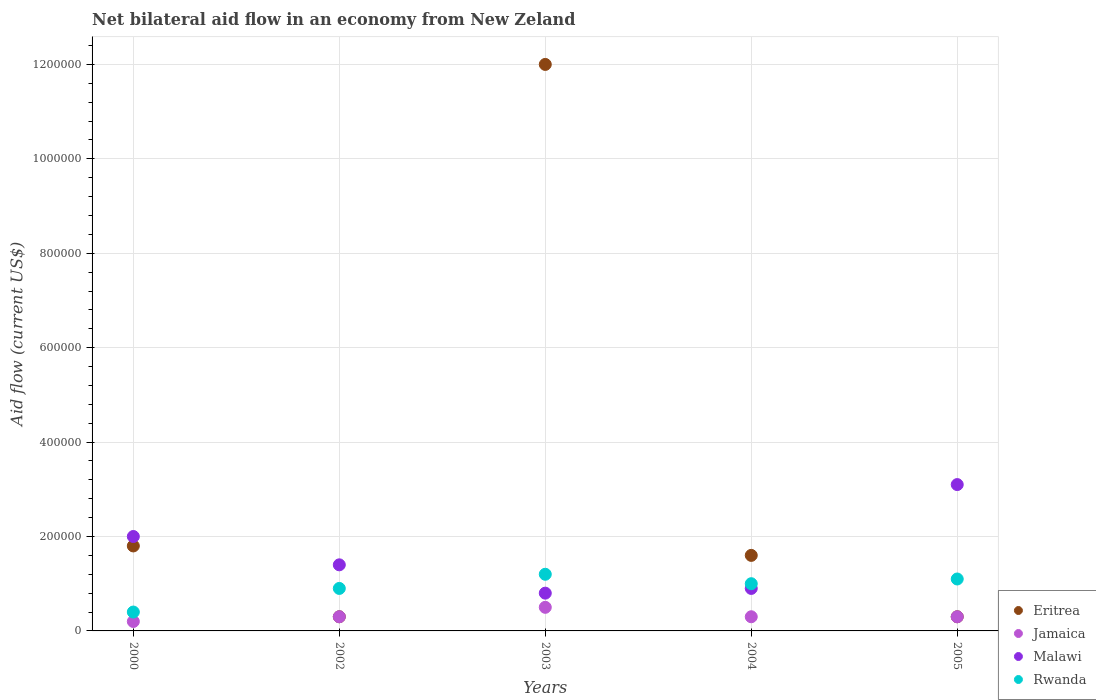How many different coloured dotlines are there?
Your answer should be compact. 4. Is the number of dotlines equal to the number of legend labels?
Keep it short and to the point. Yes. What is the net bilateral aid flow in Jamaica in 2000?
Offer a very short reply. 2.00e+04. In which year was the net bilateral aid flow in Eritrea maximum?
Provide a short and direct response. 2003. What is the total net bilateral aid flow in Eritrea in the graph?
Make the answer very short. 1.60e+06. What is the difference between the net bilateral aid flow in Jamaica in 2003 and the net bilateral aid flow in Eritrea in 2000?
Your answer should be very brief. -1.30e+05. What is the average net bilateral aid flow in Rwanda per year?
Provide a short and direct response. 9.20e+04. In the year 2000, what is the difference between the net bilateral aid flow in Malawi and net bilateral aid flow in Jamaica?
Provide a short and direct response. 1.80e+05. Is the difference between the net bilateral aid flow in Malawi in 2002 and 2004 greater than the difference between the net bilateral aid flow in Jamaica in 2002 and 2004?
Provide a succinct answer. Yes. What is the difference between the highest and the lowest net bilateral aid flow in Rwanda?
Ensure brevity in your answer.  8.00e+04. In how many years, is the net bilateral aid flow in Jamaica greater than the average net bilateral aid flow in Jamaica taken over all years?
Keep it short and to the point. 1. Is it the case that in every year, the sum of the net bilateral aid flow in Rwanda and net bilateral aid flow in Malawi  is greater than the sum of net bilateral aid flow in Eritrea and net bilateral aid flow in Jamaica?
Keep it short and to the point. Yes. Is the net bilateral aid flow in Rwanda strictly less than the net bilateral aid flow in Jamaica over the years?
Ensure brevity in your answer.  No. How many dotlines are there?
Offer a very short reply. 4. How many years are there in the graph?
Ensure brevity in your answer.  5. Does the graph contain grids?
Provide a succinct answer. Yes. How many legend labels are there?
Provide a succinct answer. 4. How are the legend labels stacked?
Ensure brevity in your answer.  Vertical. What is the title of the graph?
Offer a very short reply. Net bilateral aid flow in an economy from New Zeland. Does "Niger" appear as one of the legend labels in the graph?
Keep it short and to the point. No. What is the label or title of the X-axis?
Provide a succinct answer. Years. What is the label or title of the Y-axis?
Your answer should be compact. Aid flow (current US$). What is the Aid flow (current US$) of Jamaica in 2000?
Provide a succinct answer. 2.00e+04. What is the Aid flow (current US$) in Rwanda in 2000?
Offer a very short reply. 4.00e+04. What is the Aid flow (current US$) of Malawi in 2002?
Your answer should be compact. 1.40e+05. What is the Aid flow (current US$) of Eritrea in 2003?
Provide a short and direct response. 1.20e+06. What is the Aid flow (current US$) in Jamaica in 2003?
Provide a succinct answer. 5.00e+04. What is the Aid flow (current US$) of Rwanda in 2003?
Offer a very short reply. 1.20e+05. What is the Aid flow (current US$) of Eritrea in 2004?
Offer a terse response. 1.60e+05. What is the Aid flow (current US$) in Malawi in 2004?
Your answer should be very brief. 9.00e+04. What is the Aid flow (current US$) of Jamaica in 2005?
Your answer should be very brief. 3.00e+04. What is the Aid flow (current US$) in Rwanda in 2005?
Ensure brevity in your answer.  1.10e+05. Across all years, what is the maximum Aid flow (current US$) of Eritrea?
Ensure brevity in your answer.  1.20e+06. Across all years, what is the maximum Aid flow (current US$) in Jamaica?
Ensure brevity in your answer.  5.00e+04. Across all years, what is the maximum Aid flow (current US$) of Malawi?
Provide a succinct answer. 3.10e+05. Across all years, what is the maximum Aid flow (current US$) in Rwanda?
Give a very brief answer. 1.20e+05. Across all years, what is the minimum Aid flow (current US$) in Eritrea?
Provide a succinct answer. 3.00e+04. What is the total Aid flow (current US$) in Eritrea in the graph?
Your response must be concise. 1.60e+06. What is the total Aid flow (current US$) of Malawi in the graph?
Your response must be concise. 8.20e+05. What is the difference between the Aid flow (current US$) in Jamaica in 2000 and that in 2002?
Provide a succinct answer. -10000. What is the difference between the Aid flow (current US$) in Malawi in 2000 and that in 2002?
Make the answer very short. 6.00e+04. What is the difference between the Aid flow (current US$) in Rwanda in 2000 and that in 2002?
Ensure brevity in your answer.  -5.00e+04. What is the difference between the Aid flow (current US$) in Eritrea in 2000 and that in 2003?
Keep it short and to the point. -1.02e+06. What is the difference between the Aid flow (current US$) in Jamaica in 2000 and that in 2003?
Provide a succinct answer. -3.00e+04. What is the difference between the Aid flow (current US$) of Eritrea in 2000 and that in 2004?
Give a very brief answer. 2.00e+04. What is the difference between the Aid flow (current US$) in Jamaica in 2000 and that in 2004?
Give a very brief answer. -10000. What is the difference between the Aid flow (current US$) of Rwanda in 2000 and that in 2004?
Offer a very short reply. -6.00e+04. What is the difference between the Aid flow (current US$) in Eritrea in 2000 and that in 2005?
Give a very brief answer. 1.50e+05. What is the difference between the Aid flow (current US$) in Jamaica in 2000 and that in 2005?
Your answer should be very brief. -10000. What is the difference between the Aid flow (current US$) in Eritrea in 2002 and that in 2003?
Offer a terse response. -1.17e+06. What is the difference between the Aid flow (current US$) of Malawi in 2002 and that in 2003?
Offer a very short reply. 6.00e+04. What is the difference between the Aid flow (current US$) in Jamaica in 2002 and that in 2005?
Your answer should be very brief. 0. What is the difference between the Aid flow (current US$) of Eritrea in 2003 and that in 2004?
Provide a short and direct response. 1.04e+06. What is the difference between the Aid flow (current US$) of Jamaica in 2003 and that in 2004?
Offer a very short reply. 2.00e+04. What is the difference between the Aid flow (current US$) of Eritrea in 2003 and that in 2005?
Ensure brevity in your answer.  1.17e+06. What is the difference between the Aid flow (current US$) in Malawi in 2003 and that in 2005?
Ensure brevity in your answer.  -2.30e+05. What is the difference between the Aid flow (current US$) in Rwanda in 2003 and that in 2005?
Ensure brevity in your answer.  10000. What is the difference between the Aid flow (current US$) of Eritrea in 2004 and that in 2005?
Your response must be concise. 1.30e+05. What is the difference between the Aid flow (current US$) in Eritrea in 2000 and the Aid flow (current US$) in Malawi in 2002?
Your answer should be very brief. 4.00e+04. What is the difference between the Aid flow (current US$) in Eritrea in 2000 and the Aid flow (current US$) in Rwanda in 2002?
Make the answer very short. 9.00e+04. What is the difference between the Aid flow (current US$) in Jamaica in 2000 and the Aid flow (current US$) in Malawi in 2002?
Provide a succinct answer. -1.20e+05. What is the difference between the Aid flow (current US$) of Jamaica in 2000 and the Aid flow (current US$) of Rwanda in 2002?
Your response must be concise. -7.00e+04. What is the difference between the Aid flow (current US$) in Eritrea in 2000 and the Aid flow (current US$) in Malawi in 2003?
Your response must be concise. 1.00e+05. What is the difference between the Aid flow (current US$) in Eritrea in 2000 and the Aid flow (current US$) in Rwanda in 2003?
Your answer should be compact. 6.00e+04. What is the difference between the Aid flow (current US$) of Malawi in 2000 and the Aid flow (current US$) of Rwanda in 2003?
Offer a terse response. 8.00e+04. What is the difference between the Aid flow (current US$) of Jamaica in 2000 and the Aid flow (current US$) of Rwanda in 2004?
Keep it short and to the point. -8.00e+04. What is the difference between the Aid flow (current US$) in Malawi in 2000 and the Aid flow (current US$) in Rwanda in 2004?
Make the answer very short. 1.00e+05. What is the difference between the Aid flow (current US$) of Eritrea in 2000 and the Aid flow (current US$) of Jamaica in 2005?
Give a very brief answer. 1.50e+05. What is the difference between the Aid flow (current US$) of Eritrea in 2000 and the Aid flow (current US$) of Malawi in 2005?
Offer a very short reply. -1.30e+05. What is the difference between the Aid flow (current US$) of Eritrea in 2000 and the Aid flow (current US$) of Rwanda in 2005?
Your answer should be very brief. 7.00e+04. What is the difference between the Aid flow (current US$) of Jamaica in 2000 and the Aid flow (current US$) of Malawi in 2005?
Your answer should be compact. -2.90e+05. What is the difference between the Aid flow (current US$) of Jamaica in 2000 and the Aid flow (current US$) of Rwanda in 2005?
Make the answer very short. -9.00e+04. What is the difference between the Aid flow (current US$) of Eritrea in 2002 and the Aid flow (current US$) of Jamaica in 2003?
Offer a terse response. -2.00e+04. What is the difference between the Aid flow (current US$) of Eritrea in 2002 and the Aid flow (current US$) of Malawi in 2003?
Give a very brief answer. -5.00e+04. What is the difference between the Aid flow (current US$) of Eritrea in 2002 and the Aid flow (current US$) of Rwanda in 2003?
Give a very brief answer. -9.00e+04. What is the difference between the Aid flow (current US$) of Jamaica in 2002 and the Aid flow (current US$) of Rwanda in 2003?
Keep it short and to the point. -9.00e+04. What is the difference between the Aid flow (current US$) in Malawi in 2002 and the Aid flow (current US$) in Rwanda in 2003?
Provide a succinct answer. 2.00e+04. What is the difference between the Aid flow (current US$) in Eritrea in 2002 and the Aid flow (current US$) in Jamaica in 2004?
Your answer should be very brief. 0. What is the difference between the Aid flow (current US$) in Jamaica in 2002 and the Aid flow (current US$) in Malawi in 2004?
Your response must be concise. -6.00e+04. What is the difference between the Aid flow (current US$) in Malawi in 2002 and the Aid flow (current US$) in Rwanda in 2004?
Provide a short and direct response. 4.00e+04. What is the difference between the Aid flow (current US$) of Eritrea in 2002 and the Aid flow (current US$) of Jamaica in 2005?
Provide a short and direct response. 0. What is the difference between the Aid flow (current US$) in Eritrea in 2002 and the Aid flow (current US$) in Malawi in 2005?
Provide a short and direct response. -2.80e+05. What is the difference between the Aid flow (current US$) in Jamaica in 2002 and the Aid flow (current US$) in Malawi in 2005?
Provide a short and direct response. -2.80e+05. What is the difference between the Aid flow (current US$) of Jamaica in 2002 and the Aid flow (current US$) of Rwanda in 2005?
Your answer should be compact. -8.00e+04. What is the difference between the Aid flow (current US$) in Eritrea in 2003 and the Aid flow (current US$) in Jamaica in 2004?
Ensure brevity in your answer.  1.17e+06. What is the difference between the Aid flow (current US$) in Eritrea in 2003 and the Aid flow (current US$) in Malawi in 2004?
Ensure brevity in your answer.  1.11e+06. What is the difference between the Aid flow (current US$) of Eritrea in 2003 and the Aid flow (current US$) of Rwanda in 2004?
Provide a short and direct response. 1.10e+06. What is the difference between the Aid flow (current US$) in Jamaica in 2003 and the Aid flow (current US$) in Malawi in 2004?
Your response must be concise. -4.00e+04. What is the difference between the Aid flow (current US$) of Eritrea in 2003 and the Aid flow (current US$) of Jamaica in 2005?
Provide a succinct answer. 1.17e+06. What is the difference between the Aid flow (current US$) in Eritrea in 2003 and the Aid flow (current US$) in Malawi in 2005?
Your answer should be very brief. 8.90e+05. What is the difference between the Aid flow (current US$) in Eritrea in 2003 and the Aid flow (current US$) in Rwanda in 2005?
Offer a terse response. 1.09e+06. What is the difference between the Aid flow (current US$) of Jamaica in 2003 and the Aid flow (current US$) of Malawi in 2005?
Provide a short and direct response. -2.60e+05. What is the difference between the Aid flow (current US$) of Malawi in 2003 and the Aid flow (current US$) of Rwanda in 2005?
Ensure brevity in your answer.  -3.00e+04. What is the difference between the Aid flow (current US$) in Eritrea in 2004 and the Aid flow (current US$) in Jamaica in 2005?
Provide a succinct answer. 1.30e+05. What is the difference between the Aid flow (current US$) of Eritrea in 2004 and the Aid flow (current US$) of Malawi in 2005?
Provide a succinct answer. -1.50e+05. What is the difference between the Aid flow (current US$) of Jamaica in 2004 and the Aid flow (current US$) of Malawi in 2005?
Keep it short and to the point. -2.80e+05. What is the difference between the Aid flow (current US$) of Malawi in 2004 and the Aid flow (current US$) of Rwanda in 2005?
Provide a short and direct response. -2.00e+04. What is the average Aid flow (current US$) of Jamaica per year?
Offer a very short reply. 3.20e+04. What is the average Aid flow (current US$) in Malawi per year?
Make the answer very short. 1.64e+05. What is the average Aid flow (current US$) of Rwanda per year?
Your answer should be very brief. 9.20e+04. In the year 2000, what is the difference between the Aid flow (current US$) of Eritrea and Aid flow (current US$) of Jamaica?
Make the answer very short. 1.60e+05. In the year 2000, what is the difference between the Aid flow (current US$) in Eritrea and Aid flow (current US$) in Rwanda?
Ensure brevity in your answer.  1.40e+05. In the year 2000, what is the difference between the Aid flow (current US$) in Jamaica and Aid flow (current US$) in Malawi?
Offer a very short reply. -1.80e+05. In the year 2000, what is the difference between the Aid flow (current US$) of Jamaica and Aid flow (current US$) of Rwanda?
Offer a terse response. -2.00e+04. In the year 2002, what is the difference between the Aid flow (current US$) in Eritrea and Aid flow (current US$) in Jamaica?
Your response must be concise. 0. In the year 2002, what is the difference between the Aid flow (current US$) of Eritrea and Aid flow (current US$) of Malawi?
Provide a succinct answer. -1.10e+05. In the year 2002, what is the difference between the Aid flow (current US$) in Eritrea and Aid flow (current US$) in Rwanda?
Ensure brevity in your answer.  -6.00e+04. In the year 2002, what is the difference between the Aid flow (current US$) of Malawi and Aid flow (current US$) of Rwanda?
Offer a terse response. 5.00e+04. In the year 2003, what is the difference between the Aid flow (current US$) of Eritrea and Aid flow (current US$) of Jamaica?
Your answer should be compact. 1.15e+06. In the year 2003, what is the difference between the Aid flow (current US$) of Eritrea and Aid flow (current US$) of Malawi?
Offer a terse response. 1.12e+06. In the year 2003, what is the difference between the Aid flow (current US$) in Eritrea and Aid flow (current US$) in Rwanda?
Offer a terse response. 1.08e+06. In the year 2003, what is the difference between the Aid flow (current US$) of Malawi and Aid flow (current US$) of Rwanda?
Provide a succinct answer. -4.00e+04. In the year 2004, what is the difference between the Aid flow (current US$) in Eritrea and Aid flow (current US$) in Jamaica?
Provide a short and direct response. 1.30e+05. In the year 2004, what is the difference between the Aid flow (current US$) of Eritrea and Aid flow (current US$) of Malawi?
Make the answer very short. 7.00e+04. In the year 2004, what is the difference between the Aid flow (current US$) in Jamaica and Aid flow (current US$) in Malawi?
Provide a succinct answer. -6.00e+04. In the year 2004, what is the difference between the Aid flow (current US$) of Malawi and Aid flow (current US$) of Rwanda?
Give a very brief answer. -10000. In the year 2005, what is the difference between the Aid flow (current US$) in Eritrea and Aid flow (current US$) in Jamaica?
Your response must be concise. 0. In the year 2005, what is the difference between the Aid flow (current US$) of Eritrea and Aid flow (current US$) of Malawi?
Keep it short and to the point. -2.80e+05. In the year 2005, what is the difference between the Aid flow (current US$) of Eritrea and Aid flow (current US$) of Rwanda?
Your answer should be compact. -8.00e+04. In the year 2005, what is the difference between the Aid flow (current US$) in Jamaica and Aid flow (current US$) in Malawi?
Provide a short and direct response. -2.80e+05. In the year 2005, what is the difference between the Aid flow (current US$) of Jamaica and Aid flow (current US$) of Rwanda?
Ensure brevity in your answer.  -8.00e+04. In the year 2005, what is the difference between the Aid flow (current US$) of Malawi and Aid flow (current US$) of Rwanda?
Offer a very short reply. 2.00e+05. What is the ratio of the Aid flow (current US$) of Jamaica in 2000 to that in 2002?
Your response must be concise. 0.67. What is the ratio of the Aid flow (current US$) of Malawi in 2000 to that in 2002?
Provide a short and direct response. 1.43. What is the ratio of the Aid flow (current US$) of Rwanda in 2000 to that in 2002?
Your answer should be very brief. 0.44. What is the ratio of the Aid flow (current US$) of Jamaica in 2000 to that in 2003?
Provide a short and direct response. 0.4. What is the ratio of the Aid flow (current US$) in Rwanda in 2000 to that in 2003?
Provide a short and direct response. 0.33. What is the ratio of the Aid flow (current US$) in Eritrea in 2000 to that in 2004?
Your answer should be compact. 1.12. What is the ratio of the Aid flow (current US$) of Jamaica in 2000 to that in 2004?
Provide a short and direct response. 0.67. What is the ratio of the Aid flow (current US$) in Malawi in 2000 to that in 2004?
Provide a succinct answer. 2.22. What is the ratio of the Aid flow (current US$) of Malawi in 2000 to that in 2005?
Offer a terse response. 0.65. What is the ratio of the Aid flow (current US$) of Rwanda in 2000 to that in 2005?
Provide a succinct answer. 0.36. What is the ratio of the Aid flow (current US$) of Eritrea in 2002 to that in 2003?
Give a very brief answer. 0.03. What is the ratio of the Aid flow (current US$) in Rwanda in 2002 to that in 2003?
Your answer should be very brief. 0.75. What is the ratio of the Aid flow (current US$) in Eritrea in 2002 to that in 2004?
Offer a terse response. 0.19. What is the ratio of the Aid flow (current US$) of Malawi in 2002 to that in 2004?
Make the answer very short. 1.56. What is the ratio of the Aid flow (current US$) in Rwanda in 2002 to that in 2004?
Provide a succinct answer. 0.9. What is the ratio of the Aid flow (current US$) of Malawi in 2002 to that in 2005?
Ensure brevity in your answer.  0.45. What is the ratio of the Aid flow (current US$) in Rwanda in 2002 to that in 2005?
Offer a very short reply. 0.82. What is the ratio of the Aid flow (current US$) in Jamaica in 2003 to that in 2004?
Make the answer very short. 1.67. What is the ratio of the Aid flow (current US$) in Malawi in 2003 to that in 2004?
Provide a succinct answer. 0.89. What is the ratio of the Aid flow (current US$) of Rwanda in 2003 to that in 2004?
Provide a short and direct response. 1.2. What is the ratio of the Aid flow (current US$) in Eritrea in 2003 to that in 2005?
Keep it short and to the point. 40. What is the ratio of the Aid flow (current US$) in Malawi in 2003 to that in 2005?
Offer a very short reply. 0.26. What is the ratio of the Aid flow (current US$) of Rwanda in 2003 to that in 2005?
Offer a terse response. 1.09. What is the ratio of the Aid flow (current US$) in Eritrea in 2004 to that in 2005?
Your response must be concise. 5.33. What is the ratio of the Aid flow (current US$) in Jamaica in 2004 to that in 2005?
Offer a terse response. 1. What is the ratio of the Aid flow (current US$) in Malawi in 2004 to that in 2005?
Give a very brief answer. 0.29. What is the ratio of the Aid flow (current US$) in Rwanda in 2004 to that in 2005?
Your answer should be compact. 0.91. What is the difference between the highest and the second highest Aid flow (current US$) in Eritrea?
Make the answer very short. 1.02e+06. What is the difference between the highest and the second highest Aid flow (current US$) of Jamaica?
Give a very brief answer. 2.00e+04. What is the difference between the highest and the lowest Aid flow (current US$) of Eritrea?
Your response must be concise. 1.17e+06. What is the difference between the highest and the lowest Aid flow (current US$) in Jamaica?
Offer a terse response. 3.00e+04. What is the difference between the highest and the lowest Aid flow (current US$) of Malawi?
Give a very brief answer. 2.30e+05. What is the difference between the highest and the lowest Aid flow (current US$) of Rwanda?
Provide a short and direct response. 8.00e+04. 